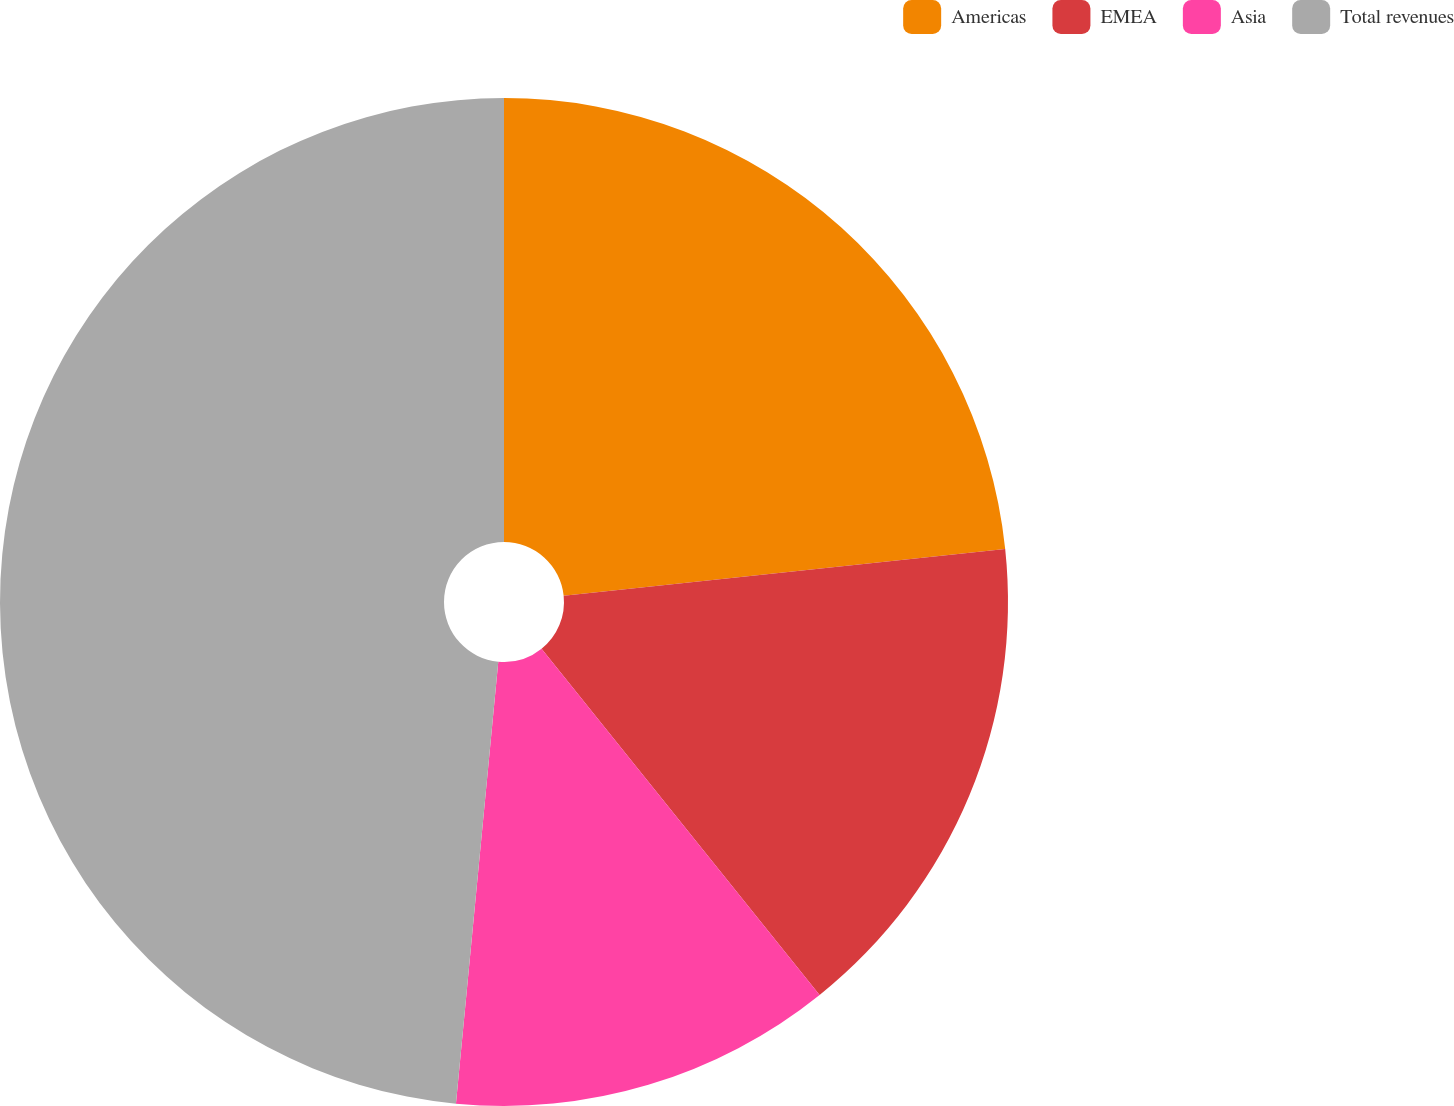<chart> <loc_0><loc_0><loc_500><loc_500><pie_chart><fcel>Americas<fcel>EMEA<fcel>Asia<fcel>Total revenues<nl><fcel>23.32%<fcel>15.91%<fcel>12.29%<fcel>48.48%<nl></chart> 